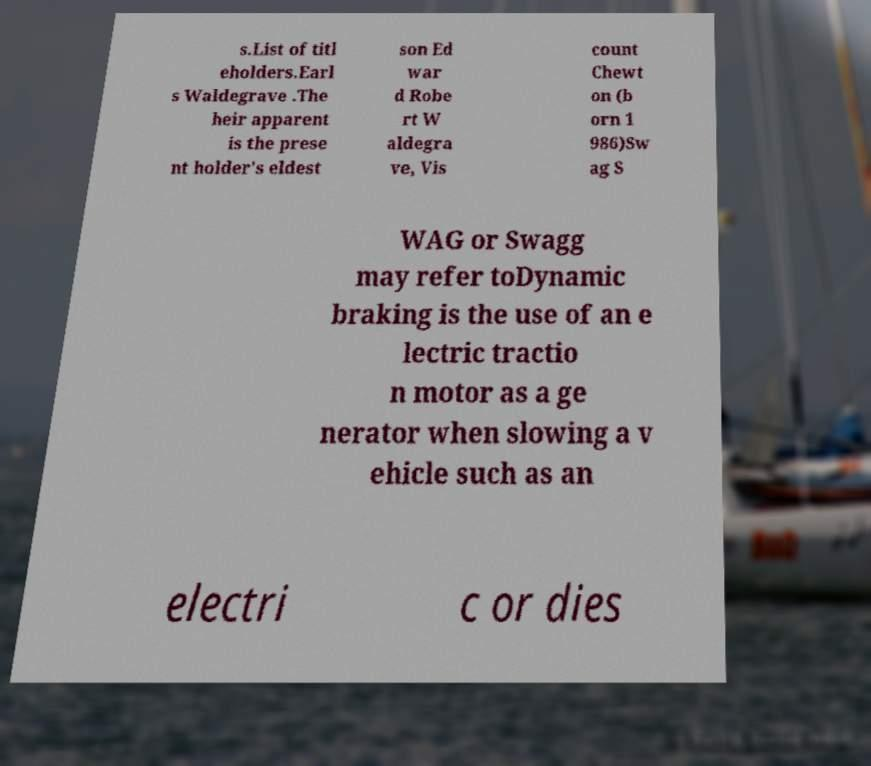What messages or text are displayed in this image? I need them in a readable, typed format. s.List of titl eholders.Earl s Waldegrave .The heir apparent is the prese nt holder's eldest son Ed war d Robe rt W aldegra ve, Vis count Chewt on (b orn 1 986)Sw ag S WAG or Swagg may refer toDynamic braking is the use of an e lectric tractio n motor as a ge nerator when slowing a v ehicle such as an electri c or dies 